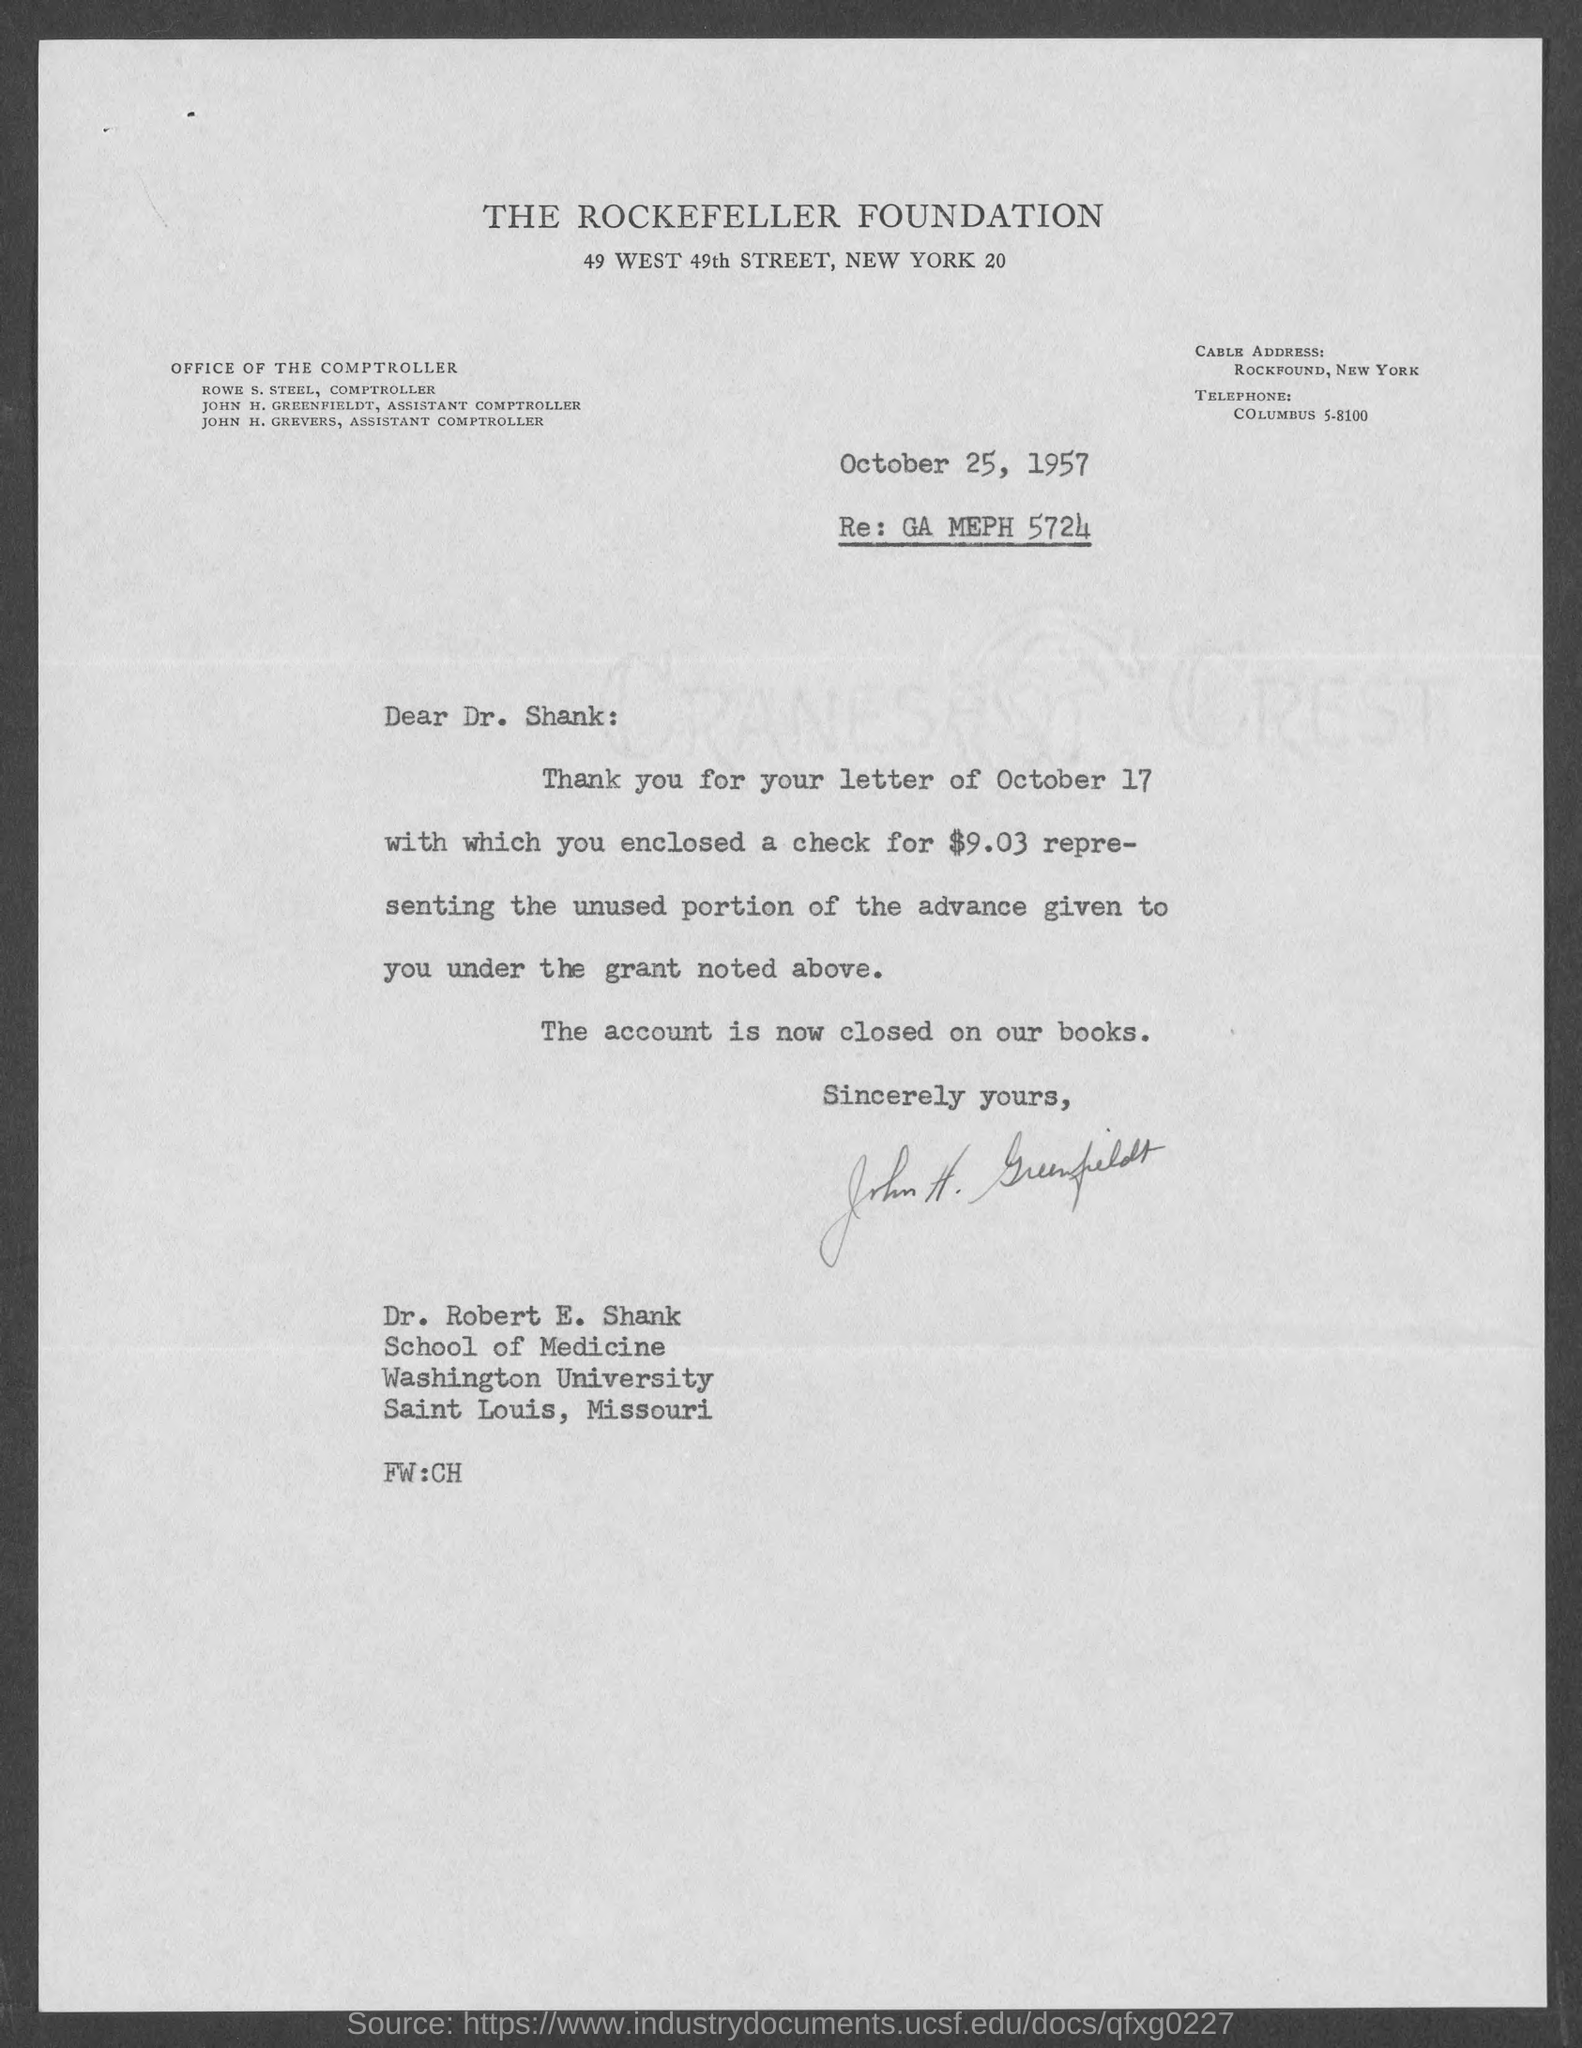What is the date mentioned in the top of the document ?
Your response must be concise. October 25, 1957. 